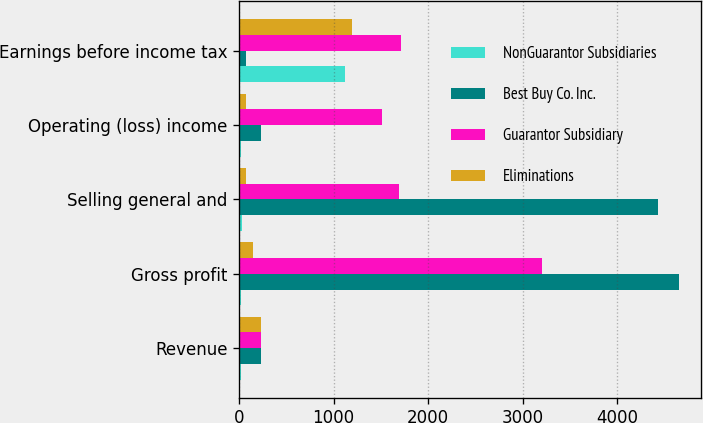<chart> <loc_0><loc_0><loc_500><loc_500><stacked_bar_chart><ecel><fcel>Revenue<fcel>Gross profit<fcel>Selling general and<fcel>Operating (loss) income<fcel>Earnings before income tax<nl><fcel>NonGuarantor Subsidiaries<fcel>17<fcel>17<fcel>34<fcel>17<fcel>1121<nl><fcel>Best Buy Co. Inc.<fcel>229<fcel>4657<fcel>4428<fcel>229<fcel>75<nl><fcel>Guarantor Subsidiary<fcel>229<fcel>3199<fcel>1690<fcel>1509<fcel>1714<nl><fcel>Eliminations<fcel>229<fcel>147<fcel>70<fcel>77<fcel>1189<nl></chart> 